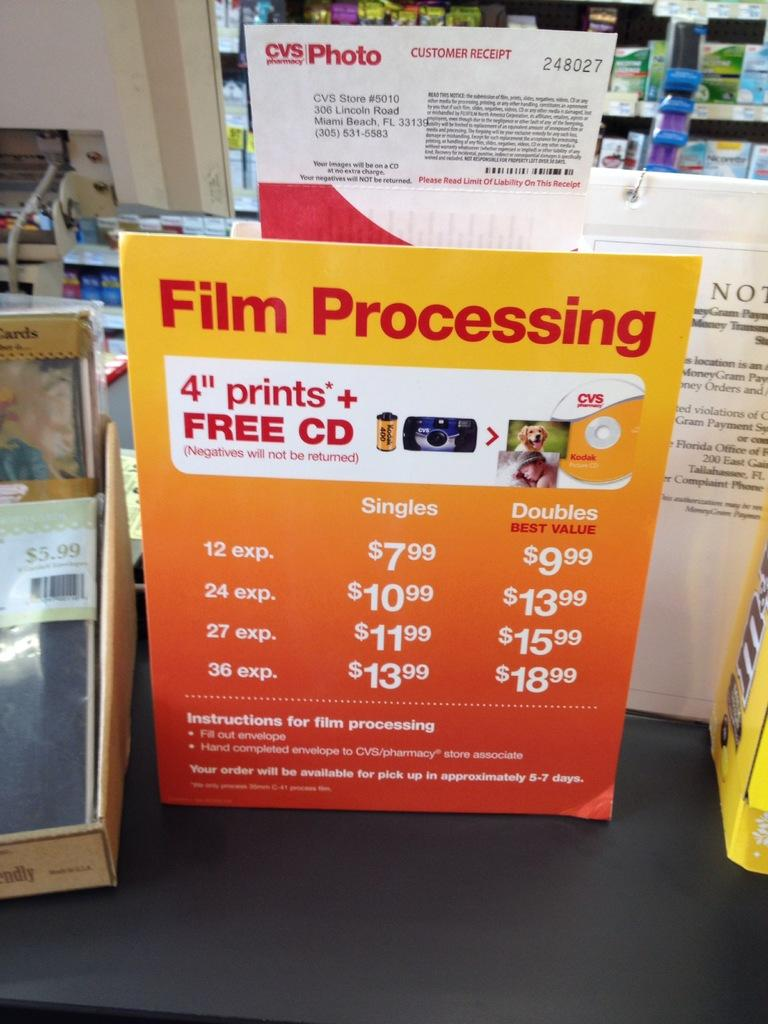<image>
Summarize the visual content of the image. Cvs photo section in a store with a poster of the prices 